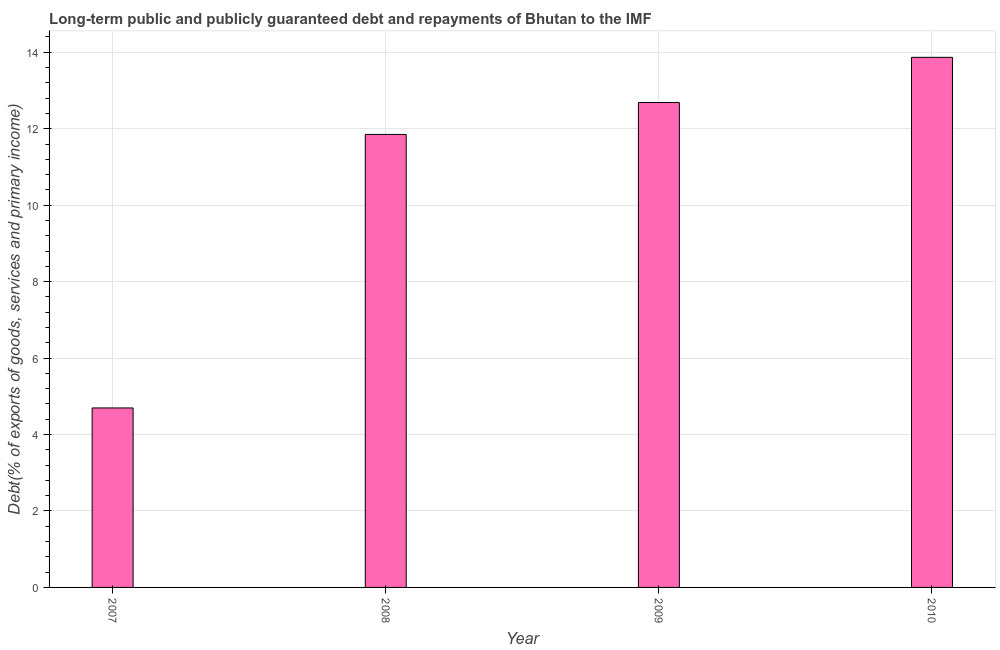Does the graph contain grids?
Your answer should be very brief. Yes. What is the title of the graph?
Keep it short and to the point. Long-term public and publicly guaranteed debt and repayments of Bhutan to the IMF. What is the label or title of the X-axis?
Provide a short and direct response. Year. What is the label or title of the Y-axis?
Offer a terse response. Debt(% of exports of goods, services and primary income). What is the debt service in 2007?
Ensure brevity in your answer.  4.7. Across all years, what is the maximum debt service?
Provide a succinct answer. 13.87. Across all years, what is the minimum debt service?
Provide a short and direct response. 4.7. In which year was the debt service maximum?
Provide a succinct answer. 2010. What is the sum of the debt service?
Provide a short and direct response. 43.1. What is the difference between the debt service in 2008 and 2009?
Make the answer very short. -0.83. What is the average debt service per year?
Your response must be concise. 10.78. What is the median debt service?
Ensure brevity in your answer.  12.27. What is the ratio of the debt service in 2007 to that in 2009?
Keep it short and to the point. 0.37. Is the debt service in 2007 less than that in 2009?
Ensure brevity in your answer.  Yes. Is the difference between the debt service in 2009 and 2010 greater than the difference between any two years?
Offer a terse response. No. What is the difference between the highest and the second highest debt service?
Your response must be concise. 1.18. What is the difference between the highest and the lowest debt service?
Make the answer very short. 9.17. How many bars are there?
Your response must be concise. 4. How many years are there in the graph?
Keep it short and to the point. 4. What is the Debt(% of exports of goods, services and primary income) in 2007?
Provide a short and direct response. 4.7. What is the Debt(% of exports of goods, services and primary income) in 2008?
Offer a very short reply. 11.85. What is the Debt(% of exports of goods, services and primary income) of 2009?
Provide a succinct answer. 12.68. What is the Debt(% of exports of goods, services and primary income) of 2010?
Your answer should be compact. 13.87. What is the difference between the Debt(% of exports of goods, services and primary income) in 2007 and 2008?
Offer a very short reply. -7.16. What is the difference between the Debt(% of exports of goods, services and primary income) in 2007 and 2009?
Your answer should be compact. -7.99. What is the difference between the Debt(% of exports of goods, services and primary income) in 2007 and 2010?
Your answer should be compact. -9.17. What is the difference between the Debt(% of exports of goods, services and primary income) in 2008 and 2009?
Keep it short and to the point. -0.83. What is the difference between the Debt(% of exports of goods, services and primary income) in 2008 and 2010?
Your response must be concise. -2.02. What is the difference between the Debt(% of exports of goods, services and primary income) in 2009 and 2010?
Offer a terse response. -1.18. What is the ratio of the Debt(% of exports of goods, services and primary income) in 2007 to that in 2008?
Provide a short and direct response. 0.4. What is the ratio of the Debt(% of exports of goods, services and primary income) in 2007 to that in 2009?
Make the answer very short. 0.37. What is the ratio of the Debt(% of exports of goods, services and primary income) in 2007 to that in 2010?
Provide a short and direct response. 0.34. What is the ratio of the Debt(% of exports of goods, services and primary income) in 2008 to that in 2009?
Your answer should be compact. 0.93. What is the ratio of the Debt(% of exports of goods, services and primary income) in 2008 to that in 2010?
Keep it short and to the point. 0.85. What is the ratio of the Debt(% of exports of goods, services and primary income) in 2009 to that in 2010?
Provide a short and direct response. 0.92. 